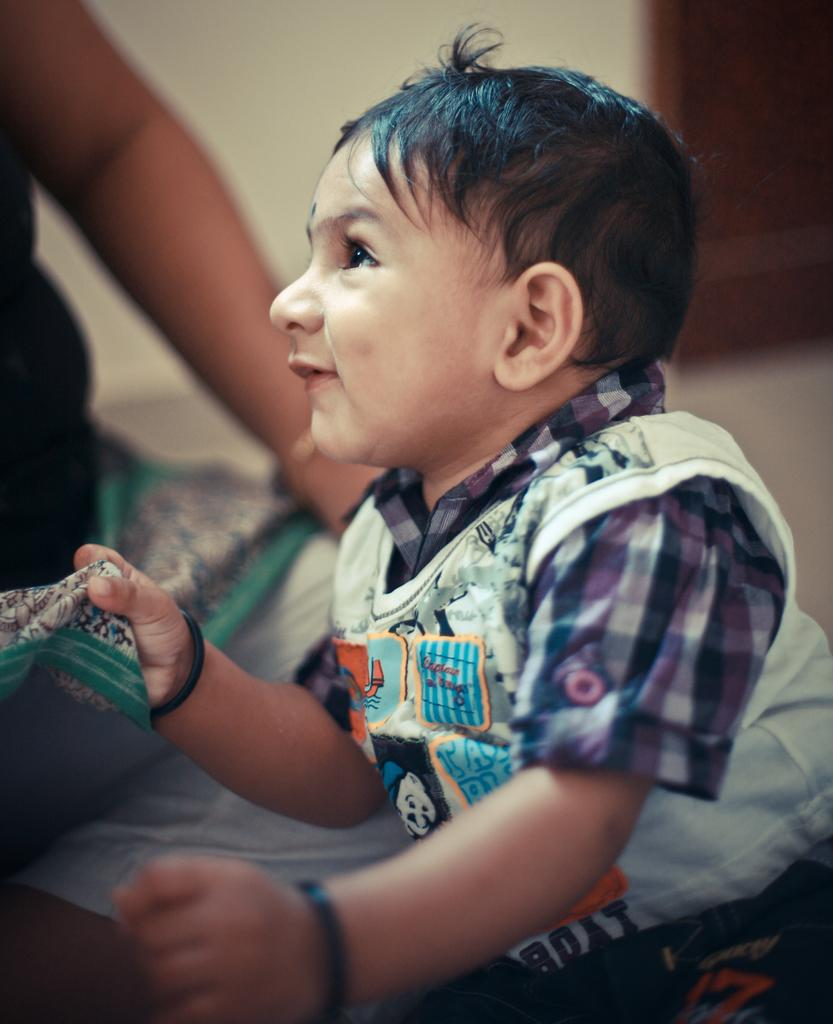What is the child in the image holding? The child is holding a dress. Who might be associated with the dress in the image? There is a person associated with the dress in the image. What can be seen in the background of the image? There is a door and a wall in the background of the image. What type of cream can be seen on the side of the tiger in the image? There is no tiger or cream present in the image. 